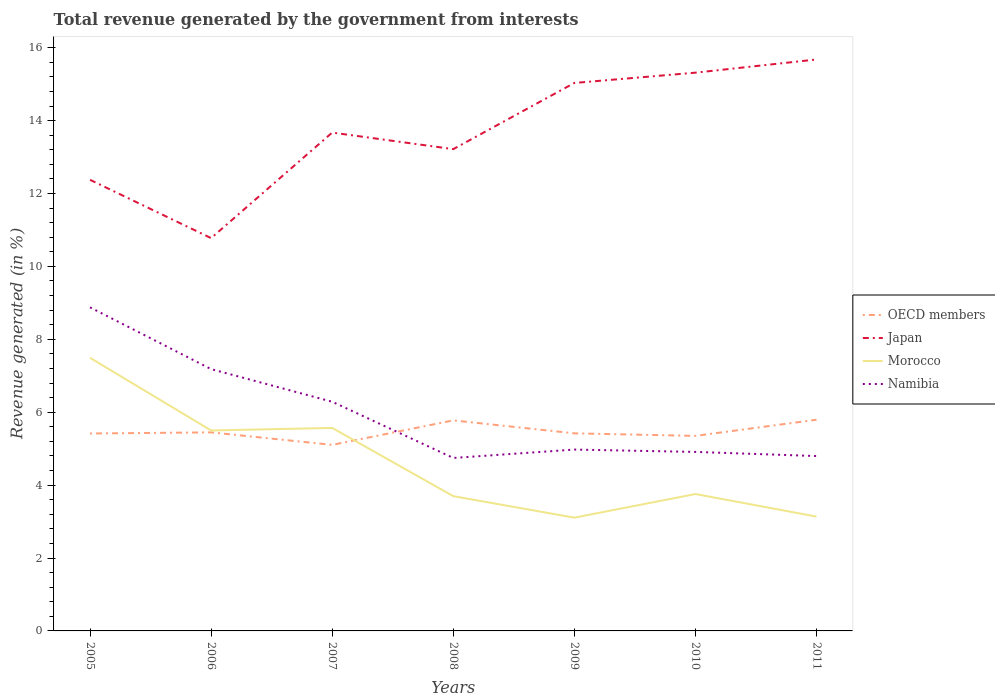Across all years, what is the maximum total revenue generated in Japan?
Give a very brief answer. 10.78. What is the total total revenue generated in Namibia in the graph?
Offer a very short reply. 0.06. What is the difference between the highest and the second highest total revenue generated in Japan?
Give a very brief answer. 4.9. What is the difference between the highest and the lowest total revenue generated in OECD members?
Your response must be concise. 2. Is the total revenue generated in Japan strictly greater than the total revenue generated in Namibia over the years?
Make the answer very short. No. What is the difference between two consecutive major ticks on the Y-axis?
Your response must be concise. 2. Are the values on the major ticks of Y-axis written in scientific E-notation?
Ensure brevity in your answer.  No. Does the graph contain any zero values?
Make the answer very short. No. How many legend labels are there?
Give a very brief answer. 4. What is the title of the graph?
Ensure brevity in your answer.  Total revenue generated by the government from interests. Does "Latvia" appear as one of the legend labels in the graph?
Provide a short and direct response. No. What is the label or title of the X-axis?
Your response must be concise. Years. What is the label or title of the Y-axis?
Provide a succinct answer. Revenue generated (in %). What is the Revenue generated (in %) of OECD members in 2005?
Your response must be concise. 5.42. What is the Revenue generated (in %) of Japan in 2005?
Make the answer very short. 12.38. What is the Revenue generated (in %) in Morocco in 2005?
Your answer should be very brief. 7.49. What is the Revenue generated (in %) in Namibia in 2005?
Ensure brevity in your answer.  8.88. What is the Revenue generated (in %) of OECD members in 2006?
Offer a terse response. 5.45. What is the Revenue generated (in %) of Japan in 2006?
Your answer should be very brief. 10.78. What is the Revenue generated (in %) of Morocco in 2006?
Ensure brevity in your answer.  5.5. What is the Revenue generated (in %) in Namibia in 2006?
Give a very brief answer. 7.18. What is the Revenue generated (in %) of OECD members in 2007?
Keep it short and to the point. 5.1. What is the Revenue generated (in %) of Japan in 2007?
Your answer should be very brief. 13.67. What is the Revenue generated (in %) of Morocco in 2007?
Provide a short and direct response. 5.57. What is the Revenue generated (in %) of Namibia in 2007?
Offer a terse response. 6.29. What is the Revenue generated (in %) of OECD members in 2008?
Keep it short and to the point. 5.78. What is the Revenue generated (in %) of Japan in 2008?
Offer a terse response. 13.22. What is the Revenue generated (in %) in Morocco in 2008?
Ensure brevity in your answer.  3.7. What is the Revenue generated (in %) of Namibia in 2008?
Keep it short and to the point. 4.75. What is the Revenue generated (in %) in OECD members in 2009?
Your response must be concise. 5.42. What is the Revenue generated (in %) in Japan in 2009?
Make the answer very short. 15.03. What is the Revenue generated (in %) in Morocco in 2009?
Offer a very short reply. 3.11. What is the Revenue generated (in %) of Namibia in 2009?
Your answer should be very brief. 4.98. What is the Revenue generated (in %) of OECD members in 2010?
Your response must be concise. 5.35. What is the Revenue generated (in %) in Japan in 2010?
Provide a succinct answer. 15.32. What is the Revenue generated (in %) in Morocco in 2010?
Keep it short and to the point. 3.76. What is the Revenue generated (in %) in Namibia in 2010?
Your response must be concise. 4.91. What is the Revenue generated (in %) of OECD members in 2011?
Offer a very short reply. 5.79. What is the Revenue generated (in %) of Japan in 2011?
Offer a terse response. 15.68. What is the Revenue generated (in %) in Morocco in 2011?
Ensure brevity in your answer.  3.14. What is the Revenue generated (in %) of Namibia in 2011?
Provide a succinct answer. 4.8. Across all years, what is the maximum Revenue generated (in %) in OECD members?
Ensure brevity in your answer.  5.79. Across all years, what is the maximum Revenue generated (in %) in Japan?
Your response must be concise. 15.68. Across all years, what is the maximum Revenue generated (in %) in Morocco?
Offer a terse response. 7.49. Across all years, what is the maximum Revenue generated (in %) of Namibia?
Your answer should be compact. 8.88. Across all years, what is the minimum Revenue generated (in %) in OECD members?
Your response must be concise. 5.1. Across all years, what is the minimum Revenue generated (in %) in Japan?
Your answer should be compact. 10.78. Across all years, what is the minimum Revenue generated (in %) in Morocco?
Keep it short and to the point. 3.11. Across all years, what is the minimum Revenue generated (in %) of Namibia?
Give a very brief answer. 4.75. What is the total Revenue generated (in %) in OECD members in the graph?
Ensure brevity in your answer.  38.31. What is the total Revenue generated (in %) in Japan in the graph?
Make the answer very short. 96.07. What is the total Revenue generated (in %) of Morocco in the graph?
Make the answer very short. 32.26. What is the total Revenue generated (in %) in Namibia in the graph?
Ensure brevity in your answer.  41.78. What is the difference between the Revenue generated (in %) in OECD members in 2005 and that in 2006?
Give a very brief answer. -0.03. What is the difference between the Revenue generated (in %) in Japan in 2005 and that in 2006?
Provide a succinct answer. 1.6. What is the difference between the Revenue generated (in %) of Morocco in 2005 and that in 2006?
Make the answer very short. 1.99. What is the difference between the Revenue generated (in %) of Namibia in 2005 and that in 2006?
Offer a very short reply. 1.69. What is the difference between the Revenue generated (in %) in OECD members in 2005 and that in 2007?
Offer a very short reply. 0.31. What is the difference between the Revenue generated (in %) of Japan in 2005 and that in 2007?
Ensure brevity in your answer.  -1.3. What is the difference between the Revenue generated (in %) in Morocco in 2005 and that in 2007?
Make the answer very short. 1.92. What is the difference between the Revenue generated (in %) of Namibia in 2005 and that in 2007?
Your answer should be compact. 2.59. What is the difference between the Revenue generated (in %) of OECD members in 2005 and that in 2008?
Your answer should be very brief. -0.36. What is the difference between the Revenue generated (in %) in Japan in 2005 and that in 2008?
Offer a very short reply. -0.84. What is the difference between the Revenue generated (in %) of Morocco in 2005 and that in 2008?
Your answer should be compact. 3.8. What is the difference between the Revenue generated (in %) in Namibia in 2005 and that in 2008?
Provide a succinct answer. 4.13. What is the difference between the Revenue generated (in %) of OECD members in 2005 and that in 2009?
Provide a succinct answer. -0. What is the difference between the Revenue generated (in %) in Japan in 2005 and that in 2009?
Offer a terse response. -2.66. What is the difference between the Revenue generated (in %) of Morocco in 2005 and that in 2009?
Your answer should be compact. 4.39. What is the difference between the Revenue generated (in %) in Namibia in 2005 and that in 2009?
Keep it short and to the point. 3.9. What is the difference between the Revenue generated (in %) of OECD members in 2005 and that in 2010?
Keep it short and to the point. 0.07. What is the difference between the Revenue generated (in %) in Japan in 2005 and that in 2010?
Your answer should be very brief. -2.94. What is the difference between the Revenue generated (in %) in Morocco in 2005 and that in 2010?
Your answer should be very brief. 3.74. What is the difference between the Revenue generated (in %) of Namibia in 2005 and that in 2010?
Your answer should be very brief. 3.97. What is the difference between the Revenue generated (in %) in OECD members in 2005 and that in 2011?
Your response must be concise. -0.38. What is the difference between the Revenue generated (in %) in Japan in 2005 and that in 2011?
Your response must be concise. -3.3. What is the difference between the Revenue generated (in %) in Morocco in 2005 and that in 2011?
Keep it short and to the point. 4.36. What is the difference between the Revenue generated (in %) of Namibia in 2005 and that in 2011?
Offer a terse response. 4.08. What is the difference between the Revenue generated (in %) of OECD members in 2006 and that in 2007?
Provide a succinct answer. 0.34. What is the difference between the Revenue generated (in %) of Japan in 2006 and that in 2007?
Your response must be concise. -2.9. What is the difference between the Revenue generated (in %) in Morocco in 2006 and that in 2007?
Your answer should be compact. -0.07. What is the difference between the Revenue generated (in %) in Namibia in 2006 and that in 2007?
Provide a succinct answer. 0.89. What is the difference between the Revenue generated (in %) in OECD members in 2006 and that in 2008?
Your answer should be very brief. -0.33. What is the difference between the Revenue generated (in %) in Japan in 2006 and that in 2008?
Keep it short and to the point. -2.44. What is the difference between the Revenue generated (in %) in Morocco in 2006 and that in 2008?
Offer a very short reply. 1.8. What is the difference between the Revenue generated (in %) in Namibia in 2006 and that in 2008?
Make the answer very short. 2.44. What is the difference between the Revenue generated (in %) of OECD members in 2006 and that in 2009?
Make the answer very short. 0.03. What is the difference between the Revenue generated (in %) of Japan in 2006 and that in 2009?
Ensure brevity in your answer.  -4.26. What is the difference between the Revenue generated (in %) in Morocco in 2006 and that in 2009?
Provide a succinct answer. 2.39. What is the difference between the Revenue generated (in %) in Namibia in 2006 and that in 2009?
Give a very brief answer. 2.21. What is the difference between the Revenue generated (in %) of OECD members in 2006 and that in 2010?
Provide a short and direct response. 0.1. What is the difference between the Revenue generated (in %) in Japan in 2006 and that in 2010?
Your response must be concise. -4.54. What is the difference between the Revenue generated (in %) of Morocco in 2006 and that in 2010?
Offer a very short reply. 1.74. What is the difference between the Revenue generated (in %) of Namibia in 2006 and that in 2010?
Offer a terse response. 2.27. What is the difference between the Revenue generated (in %) of OECD members in 2006 and that in 2011?
Provide a succinct answer. -0.35. What is the difference between the Revenue generated (in %) in Japan in 2006 and that in 2011?
Offer a very short reply. -4.9. What is the difference between the Revenue generated (in %) in Morocco in 2006 and that in 2011?
Your answer should be very brief. 2.36. What is the difference between the Revenue generated (in %) of Namibia in 2006 and that in 2011?
Provide a short and direct response. 2.38. What is the difference between the Revenue generated (in %) in OECD members in 2007 and that in 2008?
Your answer should be compact. -0.67. What is the difference between the Revenue generated (in %) of Japan in 2007 and that in 2008?
Offer a terse response. 0.45. What is the difference between the Revenue generated (in %) of Morocco in 2007 and that in 2008?
Offer a terse response. 1.87. What is the difference between the Revenue generated (in %) in Namibia in 2007 and that in 2008?
Keep it short and to the point. 1.54. What is the difference between the Revenue generated (in %) of OECD members in 2007 and that in 2009?
Make the answer very short. -0.32. What is the difference between the Revenue generated (in %) of Japan in 2007 and that in 2009?
Your response must be concise. -1.36. What is the difference between the Revenue generated (in %) in Morocco in 2007 and that in 2009?
Keep it short and to the point. 2.46. What is the difference between the Revenue generated (in %) of Namibia in 2007 and that in 2009?
Make the answer very short. 1.31. What is the difference between the Revenue generated (in %) in OECD members in 2007 and that in 2010?
Offer a very short reply. -0.25. What is the difference between the Revenue generated (in %) in Japan in 2007 and that in 2010?
Provide a succinct answer. -1.64. What is the difference between the Revenue generated (in %) in Morocco in 2007 and that in 2010?
Offer a terse response. 1.81. What is the difference between the Revenue generated (in %) of Namibia in 2007 and that in 2010?
Your answer should be compact. 1.38. What is the difference between the Revenue generated (in %) of OECD members in 2007 and that in 2011?
Your response must be concise. -0.69. What is the difference between the Revenue generated (in %) in Japan in 2007 and that in 2011?
Your response must be concise. -2.01. What is the difference between the Revenue generated (in %) of Morocco in 2007 and that in 2011?
Offer a terse response. 2.43. What is the difference between the Revenue generated (in %) in Namibia in 2007 and that in 2011?
Offer a very short reply. 1.49. What is the difference between the Revenue generated (in %) in OECD members in 2008 and that in 2009?
Provide a short and direct response. 0.36. What is the difference between the Revenue generated (in %) of Japan in 2008 and that in 2009?
Your answer should be compact. -1.82. What is the difference between the Revenue generated (in %) of Morocco in 2008 and that in 2009?
Offer a terse response. 0.59. What is the difference between the Revenue generated (in %) in Namibia in 2008 and that in 2009?
Keep it short and to the point. -0.23. What is the difference between the Revenue generated (in %) in OECD members in 2008 and that in 2010?
Your answer should be very brief. 0.42. What is the difference between the Revenue generated (in %) of Japan in 2008 and that in 2010?
Offer a very short reply. -2.1. What is the difference between the Revenue generated (in %) of Morocco in 2008 and that in 2010?
Ensure brevity in your answer.  -0.06. What is the difference between the Revenue generated (in %) in Namibia in 2008 and that in 2010?
Your answer should be very brief. -0.17. What is the difference between the Revenue generated (in %) of OECD members in 2008 and that in 2011?
Your answer should be compact. -0.02. What is the difference between the Revenue generated (in %) in Japan in 2008 and that in 2011?
Your answer should be very brief. -2.46. What is the difference between the Revenue generated (in %) of Morocco in 2008 and that in 2011?
Provide a short and direct response. 0.56. What is the difference between the Revenue generated (in %) in Namibia in 2008 and that in 2011?
Your response must be concise. -0.05. What is the difference between the Revenue generated (in %) of OECD members in 2009 and that in 2010?
Your response must be concise. 0.07. What is the difference between the Revenue generated (in %) of Japan in 2009 and that in 2010?
Your answer should be very brief. -0.28. What is the difference between the Revenue generated (in %) of Morocco in 2009 and that in 2010?
Your answer should be very brief. -0.65. What is the difference between the Revenue generated (in %) of Namibia in 2009 and that in 2010?
Provide a succinct answer. 0.06. What is the difference between the Revenue generated (in %) in OECD members in 2009 and that in 2011?
Provide a short and direct response. -0.37. What is the difference between the Revenue generated (in %) in Japan in 2009 and that in 2011?
Make the answer very short. -0.64. What is the difference between the Revenue generated (in %) in Morocco in 2009 and that in 2011?
Ensure brevity in your answer.  -0.03. What is the difference between the Revenue generated (in %) in Namibia in 2009 and that in 2011?
Your answer should be compact. 0.18. What is the difference between the Revenue generated (in %) in OECD members in 2010 and that in 2011?
Keep it short and to the point. -0.44. What is the difference between the Revenue generated (in %) of Japan in 2010 and that in 2011?
Your answer should be very brief. -0.36. What is the difference between the Revenue generated (in %) in Morocco in 2010 and that in 2011?
Provide a succinct answer. 0.62. What is the difference between the Revenue generated (in %) of Namibia in 2010 and that in 2011?
Offer a very short reply. 0.11. What is the difference between the Revenue generated (in %) of OECD members in 2005 and the Revenue generated (in %) of Japan in 2006?
Offer a terse response. -5.36. What is the difference between the Revenue generated (in %) of OECD members in 2005 and the Revenue generated (in %) of Morocco in 2006?
Offer a very short reply. -0.08. What is the difference between the Revenue generated (in %) in OECD members in 2005 and the Revenue generated (in %) in Namibia in 2006?
Offer a terse response. -1.77. What is the difference between the Revenue generated (in %) in Japan in 2005 and the Revenue generated (in %) in Morocco in 2006?
Your response must be concise. 6.88. What is the difference between the Revenue generated (in %) in Japan in 2005 and the Revenue generated (in %) in Namibia in 2006?
Ensure brevity in your answer.  5.19. What is the difference between the Revenue generated (in %) of Morocco in 2005 and the Revenue generated (in %) of Namibia in 2006?
Offer a terse response. 0.31. What is the difference between the Revenue generated (in %) in OECD members in 2005 and the Revenue generated (in %) in Japan in 2007?
Provide a short and direct response. -8.26. What is the difference between the Revenue generated (in %) in OECD members in 2005 and the Revenue generated (in %) in Morocco in 2007?
Offer a terse response. -0.15. What is the difference between the Revenue generated (in %) in OECD members in 2005 and the Revenue generated (in %) in Namibia in 2007?
Ensure brevity in your answer.  -0.87. What is the difference between the Revenue generated (in %) in Japan in 2005 and the Revenue generated (in %) in Morocco in 2007?
Ensure brevity in your answer.  6.81. What is the difference between the Revenue generated (in %) of Japan in 2005 and the Revenue generated (in %) of Namibia in 2007?
Keep it short and to the point. 6.09. What is the difference between the Revenue generated (in %) of Morocco in 2005 and the Revenue generated (in %) of Namibia in 2007?
Give a very brief answer. 1.21. What is the difference between the Revenue generated (in %) in OECD members in 2005 and the Revenue generated (in %) in Japan in 2008?
Offer a terse response. -7.8. What is the difference between the Revenue generated (in %) in OECD members in 2005 and the Revenue generated (in %) in Morocco in 2008?
Keep it short and to the point. 1.72. What is the difference between the Revenue generated (in %) in OECD members in 2005 and the Revenue generated (in %) in Namibia in 2008?
Give a very brief answer. 0.67. What is the difference between the Revenue generated (in %) of Japan in 2005 and the Revenue generated (in %) of Morocco in 2008?
Make the answer very short. 8.68. What is the difference between the Revenue generated (in %) of Japan in 2005 and the Revenue generated (in %) of Namibia in 2008?
Ensure brevity in your answer.  7.63. What is the difference between the Revenue generated (in %) in Morocco in 2005 and the Revenue generated (in %) in Namibia in 2008?
Ensure brevity in your answer.  2.75. What is the difference between the Revenue generated (in %) in OECD members in 2005 and the Revenue generated (in %) in Japan in 2009?
Keep it short and to the point. -9.62. What is the difference between the Revenue generated (in %) in OECD members in 2005 and the Revenue generated (in %) in Morocco in 2009?
Provide a short and direct response. 2.31. What is the difference between the Revenue generated (in %) of OECD members in 2005 and the Revenue generated (in %) of Namibia in 2009?
Provide a succinct answer. 0.44. What is the difference between the Revenue generated (in %) of Japan in 2005 and the Revenue generated (in %) of Morocco in 2009?
Your answer should be very brief. 9.27. What is the difference between the Revenue generated (in %) in Japan in 2005 and the Revenue generated (in %) in Namibia in 2009?
Your answer should be very brief. 7.4. What is the difference between the Revenue generated (in %) of Morocco in 2005 and the Revenue generated (in %) of Namibia in 2009?
Provide a succinct answer. 2.52. What is the difference between the Revenue generated (in %) in OECD members in 2005 and the Revenue generated (in %) in Japan in 2010?
Provide a short and direct response. -9.9. What is the difference between the Revenue generated (in %) in OECD members in 2005 and the Revenue generated (in %) in Morocco in 2010?
Keep it short and to the point. 1.66. What is the difference between the Revenue generated (in %) in OECD members in 2005 and the Revenue generated (in %) in Namibia in 2010?
Make the answer very short. 0.51. What is the difference between the Revenue generated (in %) of Japan in 2005 and the Revenue generated (in %) of Morocco in 2010?
Keep it short and to the point. 8.62. What is the difference between the Revenue generated (in %) of Japan in 2005 and the Revenue generated (in %) of Namibia in 2010?
Provide a succinct answer. 7.47. What is the difference between the Revenue generated (in %) in Morocco in 2005 and the Revenue generated (in %) in Namibia in 2010?
Your response must be concise. 2.58. What is the difference between the Revenue generated (in %) in OECD members in 2005 and the Revenue generated (in %) in Japan in 2011?
Keep it short and to the point. -10.26. What is the difference between the Revenue generated (in %) of OECD members in 2005 and the Revenue generated (in %) of Morocco in 2011?
Give a very brief answer. 2.28. What is the difference between the Revenue generated (in %) of OECD members in 2005 and the Revenue generated (in %) of Namibia in 2011?
Provide a succinct answer. 0.62. What is the difference between the Revenue generated (in %) in Japan in 2005 and the Revenue generated (in %) in Morocco in 2011?
Keep it short and to the point. 9.24. What is the difference between the Revenue generated (in %) in Japan in 2005 and the Revenue generated (in %) in Namibia in 2011?
Your answer should be compact. 7.58. What is the difference between the Revenue generated (in %) of Morocco in 2005 and the Revenue generated (in %) of Namibia in 2011?
Keep it short and to the point. 2.7. What is the difference between the Revenue generated (in %) of OECD members in 2006 and the Revenue generated (in %) of Japan in 2007?
Your answer should be compact. -8.22. What is the difference between the Revenue generated (in %) of OECD members in 2006 and the Revenue generated (in %) of Morocco in 2007?
Keep it short and to the point. -0.12. What is the difference between the Revenue generated (in %) of OECD members in 2006 and the Revenue generated (in %) of Namibia in 2007?
Keep it short and to the point. -0.84. What is the difference between the Revenue generated (in %) of Japan in 2006 and the Revenue generated (in %) of Morocco in 2007?
Offer a terse response. 5.21. What is the difference between the Revenue generated (in %) in Japan in 2006 and the Revenue generated (in %) in Namibia in 2007?
Provide a short and direct response. 4.49. What is the difference between the Revenue generated (in %) of Morocco in 2006 and the Revenue generated (in %) of Namibia in 2007?
Provide a short and direct response. -0.79. What is the difference between the Revenue generated (in %) of OECD members in 2006 and the Revenue generated (in %) of Japan in 2008?
Your answer should be compact. -7.77. What is the difference between the Revenue generated (in %) in OECD members in 2006 and the Revenue generated (in %) in Morocco in 2008?
Ensure brevity in your answer.  1.75. What is the difference between the Revenue generated (in %) in OECD members in 2006 and the Revenue generated (in %) in Namibia in 2008?
Your answer should be very brief. 0.7. What is the difference between the Revenue generated (in %) of Japan in 2006 and the Revenue generated (in %) of Morocco in 2008?
Keep it short and to the point. 7.08. What is the difference between the Revenue generated (in %) of Japan in 2006 and the Revenue generated (in %) of Namibia in 2008?
Ensure brevity in your answer.  6.03. What is the difference between the Revenue generated (in %) in Morocco in 2006 and the Revenue generated (in %) in Namibia in 2008?
Your answer should be very brief. 0.75. What is the difference between the Revenue generated (in %) in OECD members in 2006 and the Revenue generated (in %) in Japan in 2009?
Your answer should be very brief. -9.59. What is the difference between the Revenue generated (in %) of OECD members in 2006 and the Revenue generated (in %) of Morocco in 2009?
Make the answer very short. 2.34. What is the difference between the Revenue generated (in %) in OECD members in 2006 and the Revenue generated (in %) in Namibia in 2009?
Your answer should be compact. 0.47. What is the difference between the Revenue generated (in %) of Japan in 2006 and the Revenue generated (in %) of Morocco in 2009?
Give a very brief answer. 7.67. What is the difference between the Revenue generated (in %) of Japan in 2006 and the Revenue generated (in %) of Namibia in 2009?
Offer a terse response. 5.8. What is the difference between the Revenue generated (in %) of Morocco in 2006 and the Revenue generated (in %) of Namibia in 2009?
Offer a very short reply. 0.52. What is the difference between the Revenue generated (in %) in OECD members in 2006 and the Revenue generated (in %) in Japan in 2010?
Your answer should be very brief. -9.87. What is the difference between the Revenue generated (in %) in OECD members in 2006 and the Revenue generated (in %) in Morocco in 2010?
Your answer should be compact. 1.69. What is the difference between the Revenue generated (in %) in OECD members in 2006 and the Revenue generated (in %) in Namibia in 2010?
Your response must be concise. 0.54. What is the difference between the Revenue generated (in %) in Japan in 2006 and the Revenue generated (in %) in Morocco in 2010?
Your answer should be compact. 7.02. What is the difference between the Revenue generated (in %) of Japan in 2006 and the Revenue generated (in %) of Namibia in 2010?
Provide a succinct answer. 5.87. What is the difference between the Revenue generated (in %) of Morocco in 2006 and the Revenue generated (in %) of Namibia in 2010?
Give a very brief answer. 0.59. What is the difference between the Revenue generated (in %) in OECD members in 2006 and the Revenue generated (in %) in Japan in 2011?
Give a very brief answer. -10.23. What is the difference between the Revenue generated (in %) in OECD members in 2006 and the Revenue generated (in %) in Morocco in 2011?
Your response must be concise. 2.31. What is the difference between the Revenue generated (in %) of OECD members in 2006 and the Revenue generated (in %) of Namibia in 2011?
Provide a succinct answer. 0.65. What is the difference between the Revenue generated (in %) of Japan in 2006 and the Revenue generated (in %) of Morocco in 2011?
Provide a succinct answer. 7.64. What is the difference between the Revenue generated (in %) in Japan in 2006 and the Revenue generated (in %) in Namibia in 2011?
Offer a very short reply. 5.98. What is the difference between the Revenue generated (in %) of Morocco in 2006 and the Revenue generated (in %) of Namibia in 2011?
Provide a short and direct response. 0.7. What is the difference between the Revenue generated (in %) in OECD members in 2007 and the Revenue generated (in %) in Japan in 2008?
Give a very brief answer. -8.11. What is the difference between the Revenue generated (in %) in OECD members in 2007 and the Revenue generated (in %) in Morocco in 2008?
Offer a terse response. 1.41. What is the difference between the Revenue generated (in %) in OECD members in 2007 and the Revenue generated (in %) in Namibia in 2008?
Offer a terse response. 0.36. What is the difference between the Revenue generated (in %) in Japan in 2007 and the Revenue generated (in %) in Morocco in 2008?
Your response must be concise. 9.98. What is the difference between the Revenue generated (in %) of Japan in 2007 and the Revenue generated (in %) of Namibia in 2008?
Offer a very short reply. 8.93. What is the difference between the Revenue generated (in %) of Morocco in 2007 and the Revenue generated (in %) of Namibia in 2008?
Offer a very short reply. 0.82. What is the difference between the Revenue generated (in %) in OECD members in 2007 and the Revenue generated (in %) in Japan in 2009?
Ensure brevity in your answer.  -9.93. What is the difference between the Revenue generated (in %) of OECD members in 2007 and the Revenue generated (in %) of Morocco in 2009?
Make the answer very short. 2. What is the difference between the Revenue generated (in %) of OECD members in 2007 and the Revenue generated (in %) of Namibia in 2009?
Offer a terse response. 0.13. What is the difference between the Revenue generated (in %) in Japan in 2007 and the Revenue generated (in %) in Morocco in 2009?
Your response must be concise. 10.56. What is the difference between the Revenue generated (in %) of Japan in 2007 and the Revenue generated (in %) of Namibia in 2009?
Offer a very short reply. 8.7. What is the difference between the Revenue generated (in %) of Morocco in 2007 and the Revenue generated (in %) of Namibia in 2009?
Make the answer very short. 0.59. What is the difference between the Revenue generated (in %) in OECD members in 2007 and the Revenue generated (in %) in Japan in 2010?
Your answer should be compact. -10.21. What is the difference between the Revenue generated (in %) in OECD members in 2007 and the Revenue generated (in %) in Morocco in 2010?
Your response must be concise. 1.35. What is the difference between the Revenue generated (in %) in OECD members in 2007 and the Revenue generated (in %) in Namibia in 2010?
Make the answer very short. 0.19. What is the difference between the Revenue generated (in %) in Japan in 2007 and the Revenue generated (in %) in Morocco in 2010?
Offer a very short reply. 9.92. What is the difference between the Revenue generated (in %) in Japan in 2007 and the Revenue generated (in %) in Namibia in 2010?
Provide a succinct answer. 8.76. What is the difference between the Revenue generated (in %) in Morocco in 2007 and the Revenue generated (in %) in Namibia in 2010?
Offer a very short reply. 0.66. What is the difference between the Revenue generated (in %) of OECD members in 2007 and the Revenue generated (in %) of Japan in 2011?
Give a very brief answer. -10.57. What is the difference between the Revenue generated (in %) in OECD members in 2007 and the Revenue generated (in %) in Morocco in 2011?
Keep it short and to the point. 1.97. What is the difference between the Revenue generated (in %) in OECD members in 2007 and the Revenue generated (in %) in Namibia in 2011?
Give a very brief answer. 0.31. What is the difference between the Revenue generated (in %) in Japan in 2007 and the Revenue generated (in %) in Morocco in 2011?
Give a very brief answer. 10.54. What is the difference between the Revenue generated (in %) in Japan in 2007 and the Revenue generated (in %) in Namibia in 2011?
Provide a short and direct response. 8.87. What is the difference between the Revenue generated (in %) in Morocco in 2007 and the Revenue generated (in %) in Namibia in 2011?
Make the answer very short. 0.77. What is the difference between the Revenue generated (in %) in OECD members in 2008 and the Revenue generated (in %) in Japan in 2009?
Your answer should be very brief. -9.26. What is the difference between the Revenue generated (in %) of OECD members in 2008 and the Revenue generated (in %) of Morocco in 2009?
Provide a short and direct response. 2.67. What is the difference between the Revenue generated (in %) in OECD members in 2008 and the Revenue generated (in %) in Namibia in 2009?
Offer a very short reply. 0.8. What is the difference between the Revenue generated (in %) of Japan in 2008 and the Revenue generated (in %) of Morocco in 2009?
Keep it short and to the point. 10.11. What is the difference between the Revenue generated (in %) in Japan in 2008 and the Revenue generated (in %) in Namibia in 2009?
Give a very brief answer. 8.24. What is the difference between the Revenue generated (in %) of Morocco in 2008 and the Revenue generated (in %) of Namibia in 2009?
Provide a short and direct response. -1.28. What is the difference between the Revenue generated (in %) of OECD members in 2008 and the Revenue generated (in %) of Japan in 2010?
Give a very brief answer. -9.54. What is the difference between the Revenue generated (in %) in OECD members in 2008 and the Revenue generated (in %) in Morocco in 2010?
Offer a very short reply. 2.02. What is the difference between the Revenue generated (in %) of OECD members in 2008 and the Revenue generated (in %) of Namibia in 2010?
Your answer should be very brief. 0.86. What is the difference between the Revenue generated (in %) of Japan in 2008 and the Revenue generated (in %) of Morocco in 2010?
Provide a succinct answer. 9.46. What is the difference between the Revenue generated (in %) of Japan in 2008 and the Revenue generated (in %) of Namibia in 2010?
Your response must be concise. 8.31. What is the difference between the Revenue generated (in %) in Morocco in 2008 and the Revenue generated (in %) in Namibia in 2010?
Offer a terse response. -1.21. What is the difference between the Revenue generated (in %) of OECD members in 2008 and the Revenue generated (in %) of Japan in 2011?
Your answer should be very brief. -9.9. What is the difference between the Revenue generated (in %) in OECD members in 2008 and the Revenue generated (in %) in Morocco in 2011?
Provide a short and direct response. 2.64. What is the difference between the Revenue generated (in %) in OECD members in 2008 and the Revenue generated (in %) in Namibia in 2011?
Your answer should be very brief. 0.98. What is the difference between the Revenue generated (in %) in Japan in 2008 and the Revenue generated (in %) in Morocco in 2011?
Your response must be concise. 10.08. What is the difference between the Revenue generated (in %) in Japan in 2008 and the Revenue generated (in %) in Namibia in 2011?
Offer a very short reply. 8.42. What is the difference between the Revenue generated (in %) in Morocco in 2008 and the Revenue generated (in %) in Namibia in 2011?
Offer a terse response. -1.1. What is the difference between the Revenue generated (in %) in OECD members in 2009 and the Revenue generated (in %) in Japan in 2010?
Offer a very short reply. -9.89. What is the difference between the Revenue generated (in %) in OECD members in 2009 and the Revenue generated (in %) in Morocco in 2010?
Keep it short and to the point. 1.66. What is the difference between the Revenue generated (in %) in OECD members in 2009 and the Revenue generated (in %) in Namibia in 2010?
Give a very brief answer. 0.51. What is the difference between the Revenue generated (in %) in Japan in 2009 and the Revenue generated (in %) in Morocco in 2010?
Keep it short and to the point. 11.28. What is the difference between the Revenue generated (in %) of Japan in 2009 and the Revenue generated (in %) of Namibia in 2010?
Offer a very short reply. 10.12. What is the difference between the Revenue generated (in %) of Morocco in 2009 and the Revenue generated (in %) of Namibia in 2010?
Your response must be concise. -1.8. What is the difference between the Revenue generated (in %) of OECD members in 2009 and the Revenue generated (in %) of Japan in 2011?
Your answer should be compact. -10.26. What is the difference between the Revenue generated (in %) in OECD members in 2009 and the Revenue generated (in %) in Morocco in 2011?
Your response must be concise. 2.28. What is the difference between the Revenue generated (in %) of OECD members in 2009 and the Revenue generated (in %) of Namibia in 2011?
Offer a terse response. 0.62. What is the difference between the Revenue generated (in %) in Japan in 2009 and the Revenue generated (in %) in Morocco in 2011?
Your answer should be very brief. 11.9. What is the difference between the Revenue generated (in %) of Japan in 2009 and the Revenue generated (in %) of Namibia in 2011?
Provide a short and direct response. 10.24. What is the difference between the Revenue generated (in %) of Morocco in 2009 and the Revenue generated (in %) of Namibia in 2011?
Offer a very short reply. -1.69. What is the difference between the Revenue generated (in %) of OECD members in 2010 and the Revenue generated (in %) of Japan in 2011?
Offer a terse response. -10.33. What is the difference between the Revenue generated (in %) of OECD members in 2010 and the Revenue generated (in %) of Morocco in 2011?
Provide a short and direct response. 2.21. What is the difference between the Revenue generated (in %) of OECD members in 2010 and the Revenue generated (in %) of Namibia in 2011?
Ensure brevity in your answer.  0.55. What is the difference between the Revenue generated (in %) in Japan in 2010 and the Revenue generated (in %) in Morocco in 2011?
Your answer should be very brief. 12.18. What is the difference between the Revenue generated (in %) of Japan in 2010 and the Revenue generated (in %) of Namibia in 2011?
Make the answer very short. 10.52. What is the difference between the Revenue generated (in %) in Morocco in 2010 and the Revenue generated (in %) in Namibia in 2011?
Keep it short and to the point. -1.04. What is the average Revenue generated (in %) of OECD members per year?
Keep it short and to the point. 5.47. What is the average Revenue generated (in %) in Japan per year?
Offer a terse response. 13.72. What is the average Revenue generated (in %) of Morocco per year?
Make the answer very short. 4.61. What is the average Revenue generated (in %) in Namibia per year?
Give a very brief answer. 5.97. In the year 2005, what is the difference between the Revenue generated (in %) in OECD members and Revenue generated (in %) in Japan?
Keep it short and to the point. -6.96. In the year 2005, what is the difference between the Revenue generated (in %) in OECD members and Revenue generated (in %) in Morocco?
Your response must be concise. -2.08. In the year 2005, what is the difference between the Revenue generated (in %) of OECD members and Revenue generated (in %) of Namibia?
Offer a terse response. -3.46. In the year 2005, what is the difference between the Revenue generated (in %) of Japan and Revenue generated (in %) of Morocco?
Ensure brevity in your answer.  4.88. In the year 2005, what is the difference between the Revenue generated (in %) of Japan and Revenue generated (in %) of Namibia?
Offer a very short reply. 3.5. In the year 2005, what is the difference between the Revenue generated (in %) of Morocco and Revenue generated (in %) of Namibia?
Your answer should be very brief. -1.38. In the year 2006, what is the difference between the Revenue generated (in %) in OECD members and Revenue generated (in %) in Japan?
Give a very brief answer. -5.33. In the year 2006, what is the difference between the Revenue generated (in %) of OECD members and Revenue generated (in %) of Morocco?
Give a very brief answer. -0.05. In the year 2006, what is the difference between the Revenue generated (in %) in OECD members and Revenue generated (in %) in Namibia?
Make the answer very short. -1.74. In the year 2006, what is the difference between the Revenue generated (in %) in Japan and Revenue generated (in %) in Morocco?
Your answer should be compact. 5.28. In the year 2006, what is the difference between the Revenue generated (in %) in Japan and Revenue generated (in %) in Namibia?
Your answer should be compact. 3.59. In the year 2006, what is the difference between the Revenue generated (in %) of Morocco and Revenue generated (in %) of Namibia?
Your answer should be very brief. -1.68. In the year 2007, what is the difference between the Revenue generated (in %) in OECD members and Revenue generated (in %) in Japan?
Ensure brevity in your answer.  -8.57. In the year 2007, what is the difference between the Revenue generated (in %) in OECD members and Revenue generated (in %) in Morocco?
Offer a very short reply. -0.47. In the year 2007, what is the difference between the Revenue generated (in %) in OECD members and Revenue generated (in %) in Namibia?
Offer a terse response. -1.18. In the year 2007, what is the difference between the Revenue generated (in %) in Japan and Revenue generated (in %) in Morocco?
Provide a short and direct response. 8.1. In the year 2007, what is the difference between the Revenue generated (in %) of Japan and Revenue generated (in %) of Namibia?
Give a very brief answer. 7.38. In the year 2007, what is the difference between the Revenue generated (in %) of Morocco and Revenue generated (in %) of Namibia?
Your answer should be compact. -0.72. In the year 2008, what is the difference between the Revenue generated (in %) of OECD members and Revenue generated (in %) of Japan?
Make the answer very short. -7.44. In the year 2008, what is the difference between the Revenue generated (in %) of OECD members and Revenue generated (in %) of Morocco?
Your answer should be compact. 2.08. In the year 2008, what is the difference between the Revenue generated (in %) in OECD members and Revenue generated (in %) in Namibia?
Give a very brief answer. 1.03. In the year 2008, what is the difference between the Revenue generated (in %) of Japan and Revenue generated (in %) of Morocco?
Your answer should be compact. 9.52. In the year 2008, what is the difference between the Revenue generated (in %) in Japan and Revenue generated (in %) in Namibia?
Your response must be concise. 8.47. In the year 2008, what is the difference between the Revenue generated (in %) of Morocco and Revenue generated (in %) of Namibia?
Offer a very short reply. -1.05. In the year 2009, what is the difference between the Revenue generated (in %) of OECD members and Revenue generated (in %) of Japan?
Offer a very short reply. -9.61. In the year 2009, what is the difference between the Revenue generated (in %) in OECD members and Revenue generated (in %) in Morocco?
Provide a short and direct response. 2.31. In the year 2009, what is the difference between the Revenue generated (in %) in OECD members and Revenue generated (in %) in Namibia?
Keep it short and to the point. 0.45. In the year 2009, what is the difference between the Revenue generated (in %) in Japan and Revenue generated (in %) in Morocco?
Give a very brief answer. 11.93. In the year 2009, what is the difference between the Revenue generated (in %) of Japan and Revenue generated (in %) of Namibia?
Provide a short and direct response. 10.06. In the year 2009, what is the difference between the Revenue generated (in %) of Morocco and Revenue generated (in %) of Namibia?
Your answer should be very brief. -1.87. In the year 2010, what is the difference between the Revenue generated (in %) in OECD members and Revenue generated (in %) in Japan?
Your answer should be very brief. -9.96. In the year 2010, what is the difference between the Revenue generated (in %) of OECD members and Revenue generated (in %) of Morocco?
Provide a short and direct response. 1.6. In the year 2010, what is the difference between the Revenue generated (in %) in OECD members and Revenue generated (in %) in Namibia?
Offer a terse response. 0.44. In the year 2010, what is the difference between the Revenue generated (in %) in Japan and Revenue generated (in %) in Morocco?
Your response must be concise. 11.56. In the year 2010, what is the difference between the Revenue generated (in %) of Japan and Revenue generated (in %) of Namibia?
Ensure brevity in your answer.  10.4. In the year 2010, what is the difference between the Revenue generated (in %) of Morocco and Revenue generated (in %) of Namibia?
Your response must be concise. -1.16. In the year 2011, what is the difference between the Revenue generated (in %) of OECD members and Revenue generated (in %) of Japan?
Make the answer very short. -9.88. In the year 2011, what is the difference between the Revenue generated (in %) in OECD members and Revenue generated (in %) in Morocco?
Offer a terse response. 2.66. In the year 2011, what is the difference between the Revenue generated (in %) of OECD members and Revenue generated (in %) of Namibia?
Offer a very short reply. 1. In the year 2011, what is the difference between the Revenue generated (in %) in Japan and Revenue generated (in %) in Morocco?
Offer a very short reply. 12.54. In the year 2011, what is the difference between the Revenue generated (in %) of Japan and Revenue generated (in %) of Namibia?
Offer a terse response. 10.88. In the year 2011, what is the difference between the Revenue generated (in %) of Morocco and Revenue generated (in %) of Namibia?
Keep it short and to the point. -1.66. What is the ratio of the Revenue generated (in %) of OECD members in 2005 to that in 2006?
Give a very brief answer. 0.99. What is the ratio of the Revenue generated (in %) of Japan in 2005 to that in 2006?
Provide a succinct answer. 1.15. What is the ratio of the Revenue generated (in %) of Morocco in 2005 to that in 2006?
Keep it short and to the point. 1.36. What is the ratio of the Revenue generated (in %) of Namibia in 2005 to that in 2006?
Offer a terse response. 1.24. What is the ratio of the Revenue generated (in %) in OECD members in 2005 to that in 2007?
Ensure brevity in your answer.  1.06. What is the ratio of the Revenue generated (in %) in Japan in 2005 to that in 2007?
Offer a very short reply. 0.91. What is the ratio of the Revenue generated (in %) in Morocco in 2005 to that in 2007?
Provide a short and direct response. 1.35. What is the ratio of the Revenue generated (in %) in Namibia in 2005 to that in 2007?
Offer a very short reply. 1.41. What is the ratio of the Revenue generated (in %) in OECD members in 2005 to that in 2008?
Keep it short and to the point. 0.94. What is the ratio of the Revenue generated (in %) in Japan in 2005 to that in 2008?
Give a very brief answer. 0.94. What is the ratio of the Revenue generated (in %) in Morocco in 2005 to that in 2008?
Provide a short and direct response. 2.03. What is the ratio of the Revenue generated (in %) of Namibia in 2005 to that in 2008?
Offer a very short reply. 1.87. What is the ratio of the Revenue generated (in %) of OECD members in 2005 to that in 2009?
Your answer should be compact. 1. What is the ratio of the Revenue generated (in %) of Japan in 2005 to that in 2009?
Give a very brief answer. 0.82. What is the ratio of the Revenue generated (in %) in Morocco in 2005 to that in 2009?
Provide a short and direct response. 2.41. What is the ratio of the Revenue generated (in %) of Namibia in 2005 to that in 2009?
Offer a very short reply. 1.78. What is the ratio of the Revenue generated (in %) in OECD members in 2005 to that in 2010?
Give a very brief answer. 1.01. What is the ratio of the Revenue generated (in %) in Japan in 2005 to that in 2010?
Provide a succinct answer. 0.81. What is the ratio of the Revenue generated (in %) in Morocco in 2005 to that in 2010?
Offer a very short reply. 2. What is the ratio of the Revenue generated (in %) of Namibia in 2005 to that in 2010?
Offer a very short reply. 1.81. What is the ratio of the Revenue generated (in %) in OECD members in 2005 to that in 2011?
Give a very brief answer. 0.93. What is the ratio of the Revenue generated (in %) in Japan in 2005 to that in 2011?
Your answer should be very brief. 0.79. What is the ratio of the Revenue generated (in %) in Morocco in 2005 to that in 2011?
Offer a very short reply. 2.39. What is the ratio of the Revenue generated (in %) of Namibia in 2005 to that in 2011?
Offer a very short reply. 1.85. What is the ratio of the Revenue generated (in %) of OECD members in 2006 to that in 2007?
Offer a terse response. 1.07. What is the ratio of the Revenue generated (in %) in Japan in 2006 to that in 2007?
Your answer should be compact. 0.79. What is the ratio of the Revenue generated (in %) of Morocco in 2006 to that in 2007?
Keep it short and to the point. 0.99. What is the ratio of the Revenue generated (in %) in Namibia in 2006 to that in 2007?
Keep it short and to the point. 1.14. What is the ratio of the Revenue generated (in %) in OECD members in 2006 to that in 2008?
Your response must be concise. 0.94. What is the ratio of the Revenue generated (in %) of Japan in 2006 to that in 2008?
Offer a very short reply. 0.82. What is the ratio of the Revenue generated (in %) in Morocco in 2006 to that in 2008?
Your answer should be compact. 1.49. What is the ratio of the Revenue generated (in %) in Namibia in 2006 to that in 2008?
Your answer should be compact. 1.51. What is the ratio of the Revenue generated (in %) in Japan in 2006 to that in 2009?
Offer a terse response. 0.72. What is the ratio of the Revenue generated (in %) of Morocco in 2006 to that in 2009?
Make the answer very short. 1.77. What is the ratio of the Revenue generated (in %) in Namibia in 2006 to that in 2009?
Provide a short and direct response. 1.44. What is the ratio of the Revenue generated (in %) of OECD members in 2006 to that in 2010?
Keep it short and to the point. 1.02. What is the ratio of the Revenue generated (in %) in Japan in 2006 to that in 2010?
Your response must be concise. 0.7. What is the ratio of the Revenue generated (in %) of Morocco in 2006 to that in 2010?
Keep it short and to the point. 1.46. What is the ratio of the Revenue generated (in %) of Namibia in 2006 to that in 2010?
Offer a terse response. 1.46. What is the ratio of the Revenue generated (in %) of OECD members in 2006 to that in 2011?
Your answer should be compact. 0.94. What is the ratio of the Revenue generated (in %) of Japan in 2006 to that in 2011?
Provide a succinct answer. 0.69. What is the ratio of the Revenue generated (in %) in Morocco in 2006 to that in 2011?
Your response must be concise. 1.75. What is the ratio of the Revenue generated (in %) in Namibia in 2006 to that in 2011?
Offer a terse response. 1.5. What is the ratio of the Revenue generated (in %) of OECD members in 2007 to that in 2008?
Your answer should be very brief. 0.88. What is the ratio of the Revenue generated (in %) of Japan in 2007 to that in 2008?
Provide a succinct answer. 1.03. What is the ratio of the Revenue generated (in %) in Morocco in 2007 to that in 2008?
Your response must be concise. 1.51. What is the ratio of the Revenue generated (in %) in Namibia in 2007 to that in 2008?
Provide a short and direct response. 1.33. What is the ratio of the Revenue generated (in %) of OECD members in 2007 to that in 2009?
Your answer should be compact. 0.94. What is the ratio of the Revenue generated (in %) of Japan in 2007 to that in 2009?
Provide a short and direct response. 0.91. What is the ratio of the Revenue generated (in %) of Morocco in 2007 to that in 2009?
Give a very brief answer. 1.79. What is the ratio of the Revenue generated (in %) of Namibia in 2007 to that in 2009?
Ensure brevity in your answer.  1.26. What is the ratio of the Revenue generated (in %) in OECD members in 2007 to that in 2010?
Make the answer very short. 0.95. What is the ratio of the Revenue generated (in %) of Japan in 2007 to that in 2010?
Make the answer very short. 0.89. What is the ratio of the Revenue generated (in %) of Morocco in 2007 to that in 2010?
Offer a terse response. 1.48. What is the ratio of the Revenue generated (in %) in Namibia in 2007 to that in 2010?
Your answer should be very brief. 1.28. What is the ratio of the Revenue generated (in %) of OECD members in 2007 to that in 2011?
Provide a succinct answer. 0.88. What is the ratio of the Revenue generated (in %) of Japan in 2007 to that in 2011?
Make the answer very short. 0.87. What is the ratio of the Revenue generated (in %) of Morocco in 2007 to that in 2011?
Your response must be concise. 1.78. What is the ratio of the Revenue generated (in %) of Namibia in 2007 to that in 2011?
Provide a succinct answer. 1.31. What is the ratio of the Revenue generated (in %) of OECD members in 2008 to that in 2009?
Keep it short and to the point. 1.07. What is the ratio of the Revenue generated (in %) of Japan in 2008 to that in 2009?
Ensure brevity in your answer.  0.88. What is the ratio of the Revenue generated (in %) in Morocco in 2008 to that in 2009?
Offer a terse response. 1.19. What is the ratio of the Revenue generated (in %) of Namibia in 2008 to that in 2009?
Your answer should be very brief. 0.95. What is the ratio of the Revenue generated (in %) in OECD members in 2008 to that in 2010?
Your answer should be very brief. 1.08. What is the ratio of the Revenue generated (in %) in Japan in 2008 to that in 2010?
Keep it short and to the point. 0.86. What is the ratio of the Revenue generated (in %) of Morocco in 2008 to that in 2010?
Make the answer very short. 0.98. What is the ratio of the Revenue generated (in %) of Namibia in 2008 to that in 2010?
Your response must be concise. 0.97. What is the ratio of the Revenue generated (in %) in OECD members in 2008 to that in 2011?
Provide a succinct answer. 1. What is the ratio of the Revenue generated (in %) in Japan in 2008 to that in 2011?
Provide a short and direct response. 0.84. What is the ratio of the Revenue generated (in %) in Morocco in 2008 to that in 2011?
Give a very brief answer. 1.18. What is the ratio of the Revenue generated (in %) of OECD members in 2009 to that in 2010?
Offer a very short reply. 1.01. What is the ratio of the Revenue generated (in %) in Japan in 2009 to that in 2010?
Make the answer very short. 0.98. What is the ratio of the Revenue generated (in %) of Morocco in 2009 to that in 2010?
Your response must be concise. 0.83. What is the ratio of the Revenue generated (in %) of Namibia in 2009 to that in 2010?
Ensure brevity in your answer.  1.01. What is the ratio of the Revenue generated (in %) in OECD members in 2009 to that in 2011?
Offer a terse response. 0.94. What is the ratio of the Revenue generated (in %) in Japan in 2009 to that in 2011?
Give a very brief answer. 0.96. What is the ratio of the Revenue generated (in %) in Morocco in 2009 to that in 2011?
Your response must be concise. 0.99. What is the ratio of the Revenue generated (in %) of OECD members in 2010 to that in 2011?
Keep it short and to the point. 0.92. What is the ratio of the Revenue generated (in %) of Japan in 2010 to that in 2011?
Provide a succinct answer. 0.98. What is the ratio of the Revenue generated (in %) of Morocco in 2010 to that in 2011?
Make the answer very short. 1.2. What is the ratio of the Revenue generated (in %) in Namibia in 2010 to that in 2011?
Make the answer very short. 1.02. What is the difference between the highest and the second highest Revenue generated (in %) in OECD members?
Provide a succinct answer. 0.02. What is the difference between the highest and the second highest Revenue generated (in %) in Japan?
Ensure brevity in your answer.  0.36. What is the difference between the highest and the second highest Revenue generated (in %) of Morocco?
Make the answer very short. 1.92. What is the difference between the highest and the second highest Revenue generated (in %) in Namibia?
Ensure brevity in your answer.  1.69. What is the difference between the highest and the lowest Revenue generated (in %) in OECD members?
Give a very brief answer. 0.69. What is the difference between the highest and the lowest Revenue generated (in %) in Japan?
Provide a succinct answer. 4.9. What is the difference between the highest and the lowest Revenue generated (in %) in Morocco?
Your answer should be compact. 4.39. What is the difference between the highest and the lowest Revenue generated (in %) in Namibia?
Offer a terse response. 4.13. 